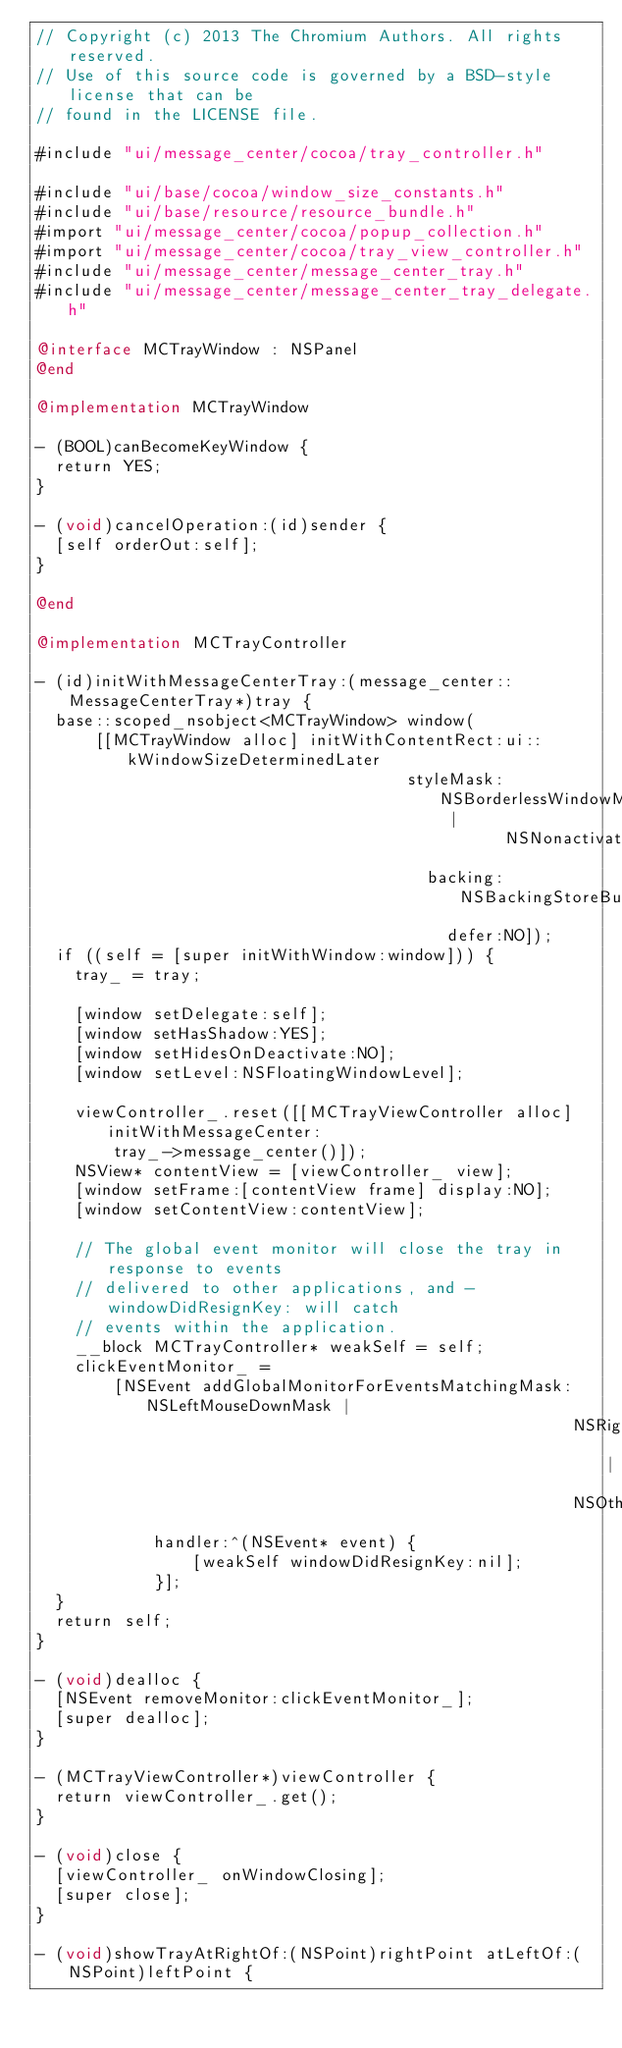Convert code to text. <code><loc_0><loc_0><loc_500><loc_500><_ObjectiveC_>// Copyright (c) 2013 The Chromium Authors. All rights reserved.
// Use of this source code is governed by a BSD-style license that can be
// found in the LICENSE file.

#include "ui/message_center/cocoa/tray_controller.h"

#include "ui/base/cocoa/window_size_constants.h"
#include "ui/base/resource/resource_bundle.h"
#import "ui/message_center/cocoa/popup_collection.h"
#import "ui/message_center/cocoa/tray_view_controller.h"
#include "ui/message_center/message_center_tray.h"
#include "ui/message_center/message_center_tray_delegate.h"

@interface MCTrayWindow : NSPanel
@end

@implementation MCTrayWindow

- (BOOL)canBecomeKeyWindow {
  return YES;
}

- (void)cancelOperation:(id)sender {
  [self orderOut:self];
}

@end

@implementation MCTrayController

- (id)initWithMessageCenterTray:(message_center::MessageCenterTray*)tray {
  base::scoped_nsobject<MCTrayWindow> window(
      [[MCTrayWindow alloc] initWithContentRect:ui::kWindowSizeDeterminedLater
                                      styleMask:NSBorderlessWindowMask |
                                                NSNonactivatingPanelMask
                                        backing:NSBackingStoreBuffered
                                          defer:NO]);
  if ((self = [super initWithWindow:window])) {
    tray_ = tray;

    [window setDelegate:self];
    [window setHasShadow:YES];
    [window setHidesOnDeactivate:NO];
    [window setLevel:NSFloatingWindowLevel];

    viewController_.reset([[MCTrayViewController alloc] initWithMessageCenter:
        tray_->message_center()]);
    NSView* contentView = [viewController_ view];
    [window setFrame:[contentView frame] display:NO];
    [window setContentView:contentView];

    // The global event monitor will close the tray in response to events
    // delivered to other applications, and -windowDidResignKey: will catch
    // events within the application.
    __block MCTrayController* weakSelf = self;
    clickEventMonitor_ =
        [NSEvent addGlobalMonitorForEventsMatchingMask:NSLeftMouseDownMask |
                                                       NSRightMouseDownMask |
                                                       NSOtherMouseDownMask
            handler:^(NSEvent* event) {
                [weakSelf windowDidResignKey:nil];
            }];
  }
  return self;
}

- (void)dealloc {
  [NSEvent removeMonitor:clickEventMonitor_];
  [super dealloc];
}

- (MCTrayViewController*)viewController {
  return viewController_.get();
}

- (void)close {
  [viewController_ onWindowClosing];
  [super close];
}

- (void)showTrayAtRightOf:(NSPoint)rightPoint atLeftOf:(NSPoint)leftPoint {</code> 